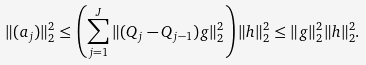Convert formula to latex. <formula><loc_0><loc_0><loc_500><loc_500>\| ( a _ { j } ) \| _ { 2 } ^ { 2 } \leq \left ( \sum _ { j = 1 } ^ { J } \| ( Q _ { j } - Q _ { j - 1 } ) g \| _ { 2 } ^ { 2 } \right ) \| h \| _ { 2 } ^ { 2 } \leq \| g \| _ { 2 } ^ { 2 } \| h \| _ { 2 } ^ { 2 } .</formula> 